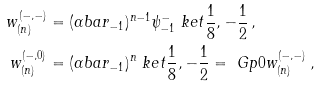<formula> <loc_0><loc_0><loc_500><loc_500>w ^ { ( - , - ) } _ { ( n ) } & = ( \alpha b a r _ { - 1 } ) ^ { n - 1 } \psi ^ { - } _ { - 1 } \ k e t { \frac { 1 } { 8 } , - \frac { 1 } { 2 } } \, , \\ w ^ { ( - , 0 ) } _ { ( n ) } & = ( \alpha b a r _ { - 1 } ) ^ { n } \ k e t { \frac { 1 } { 8 } , - \frac { 1 } { 2 } } = \ G p { 0 } w ^ { ( - , - ) } _ { ( n ) } \, ,</formula> 